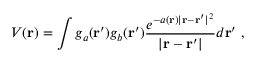<formula> <loc_0><loc_0><loc_500><loc_500>V ( r ) = \int g _ { a } ( r ^ { \prime } ) g _ { b } ( r ^ { \prime } ) \frac { e ^ { - a ( r ) | r - r ^ { \prime } | ^ { 2 } } } { | r - r ^ { \prime } | } d r ^ { \prime } \ ,</formula> 